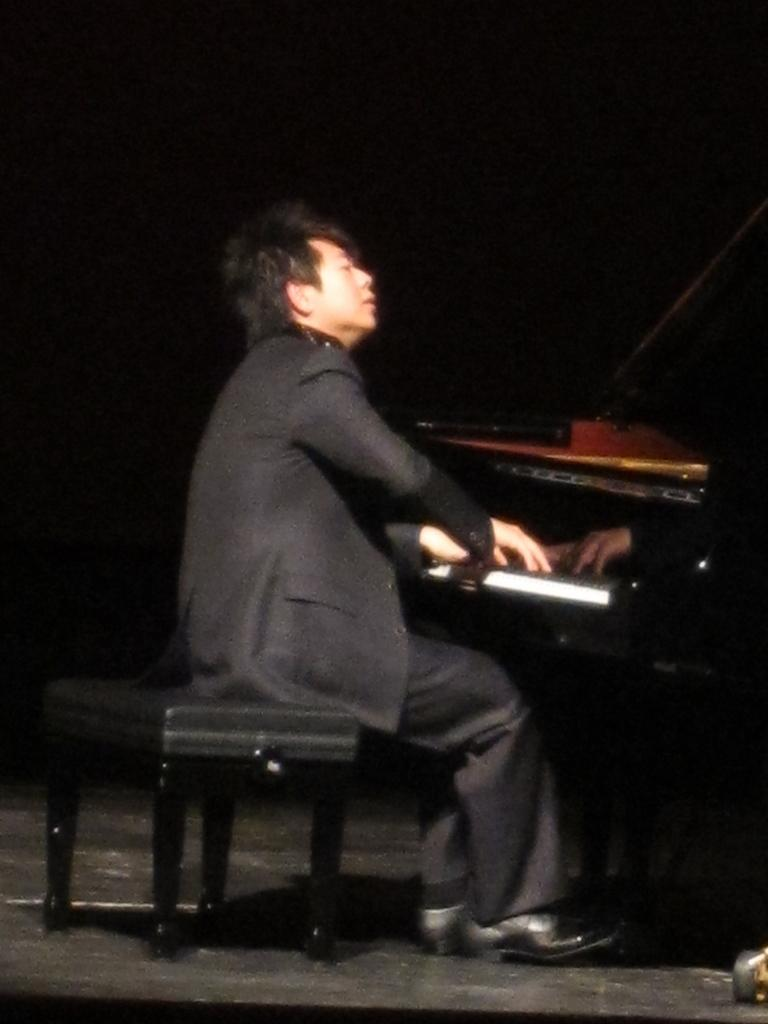Who is the main subject in the image? There is a man in the image. What is the man doing in the image? The man is playing the piano. Where is the piano located in the image? The piano is placed at the right side of the image. What is the man sitting on while playing the piano? The man is sitting on a stool. What type of fiction is the man reading while playing the piano? There is no indication in the image that the man is reading any fiction; he is focused on playing the piano. What color is the man's hair in the image? The provided facts do not mention the man's hair color, so it cannot be determined from the image. 